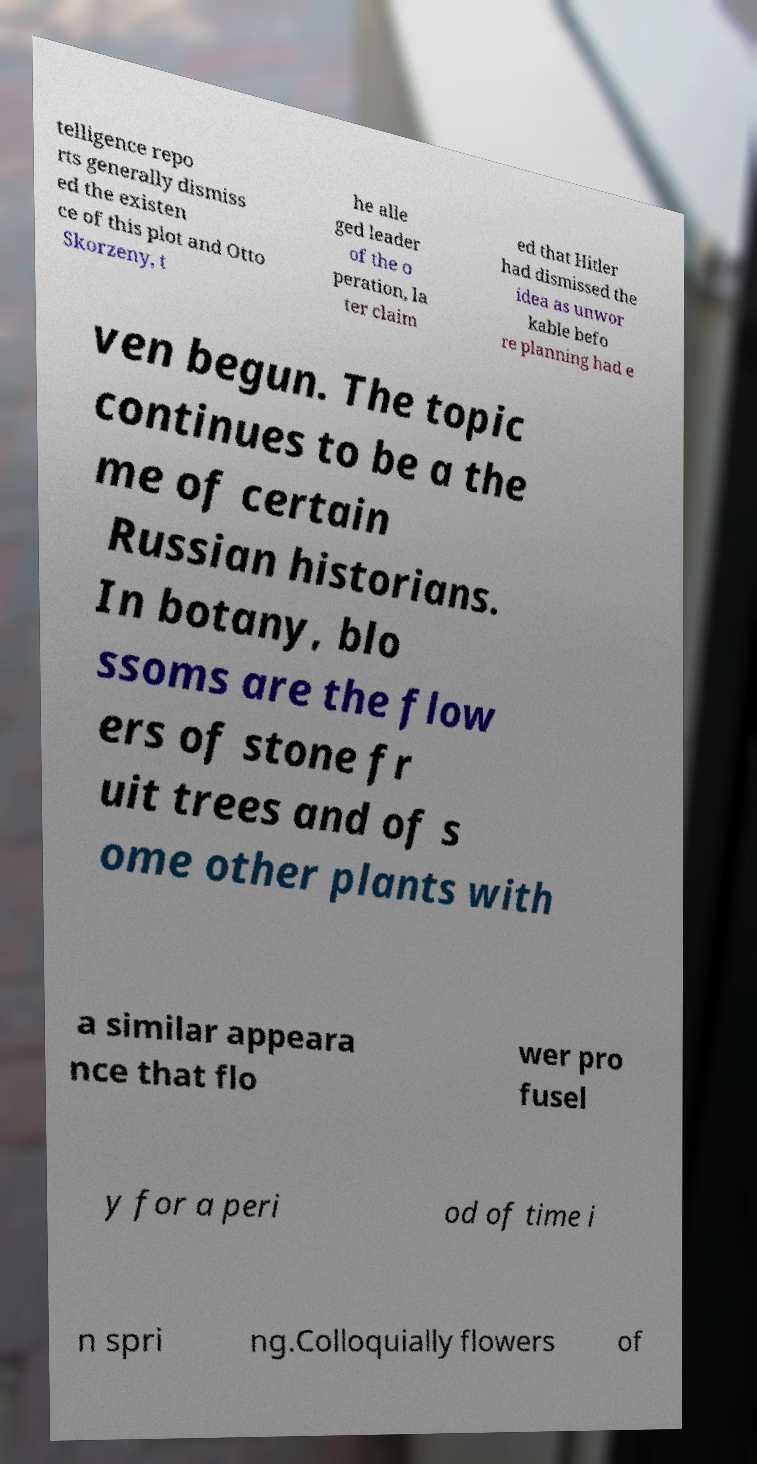There's text embedded in this image that I need extracted. Can you transcribe it verbatim? telligence repo rts generally dismiss ed the existen ce of this plot and Otto Skorzeny, t he alle ged leader of the o peration, la ter claim ed that Hitler had dismissed the idea as unwor kable befo re planning had e ven begun. The topic continues to be a the me of certain Russian historians. In botany, blo ssoms are the flow ers of stone fr uit trees and of s ome other plants with a similar appeara nce that flo wer pro fusel y for a peri od of time i n spri ng.Colloquially flowers of 